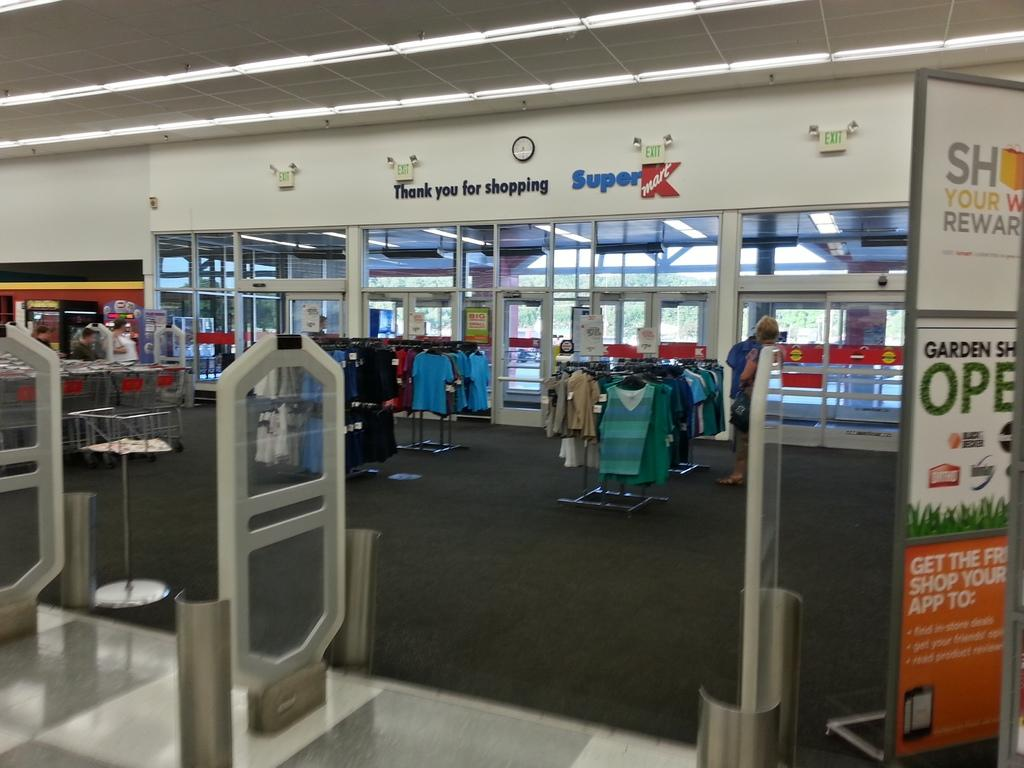Provide a one-sentence caption for the provided image. The exit to Super Kmart, including the safety rails you must pass. 